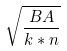Convert formula to latex. <formula><loc_0><loc_0><loc_500><loc_500>\sqrt { \frac { B A } { k * n } }</formula> 